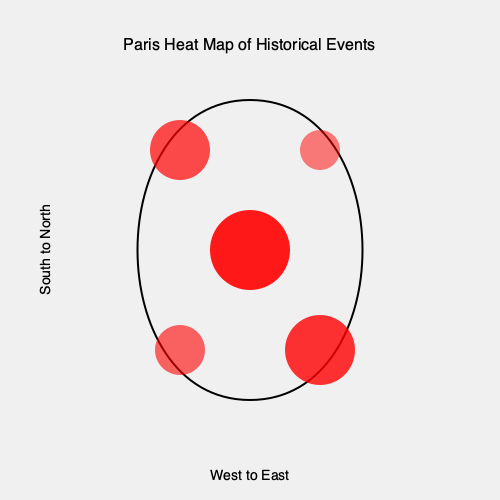Based on the heat map overlay of historical events in Paris, which area of the city appears to have the highest concentration of significant historical occurrences, and what might be a plausible explanation for this concentration? To answer this question, we need to analyze the heat map overlay on the Paris city map:

1. Observe the distribution of red circles: The red circles represent the concentration of historical events, with larger and more opaque circles indicating a higher number of events.

2. Identify the largest and most opaque circle: The circle in the center of the map is the largest and has the highest opacity, indicating the highest concentration of historical events.

3. Determine the geographical location: The center of Paris typically corresponds to the area around the Île de la Cité and the 1st arrondissement.

4. Consider historical context: This central area includes landmarks such as Notre-Dame Cathedral, the Louvre, and the Palais Royal, which have been at the heart of Parisian history for centuries.

5. Analyze the historical significance: The center of Paris has been the seat of power, religion, and culture since the city's founding, making it a natural focal point for historical events.

6. Compare to other areas: While other parts of the city show significant historical activity, none match the concentration in the center.

7. Conclude: The central area of Paris, around the Île de la Cité and the 1st arrondissement, has the highest concentration of historical events due to its longstanding importance as the city's political, religious, and cultural core.
Answer: Central Paris (Île de la Cité/1st arrondissement); historical seat of power, religion, and culture. 